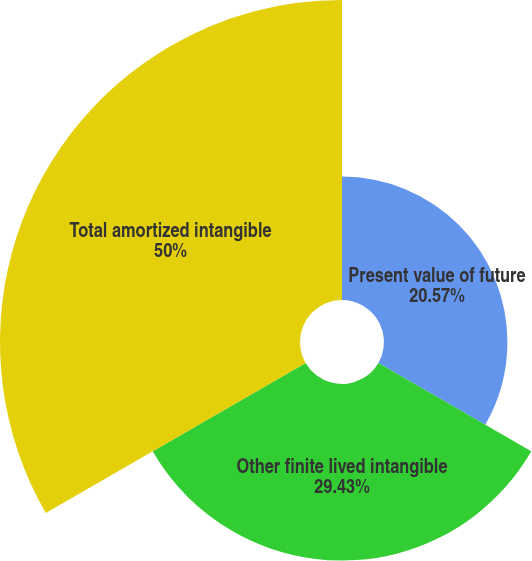Convert chart. <chart><loc_0><loc_0><loc_500><loc_500><pie_chart><fcel>Present value of future<fcel>Other finite lived intangible<fcel>Total amortized intangible<nl><fcel>20.57%<fcel>29.43%<fcel>50.0%<nl></chart> 